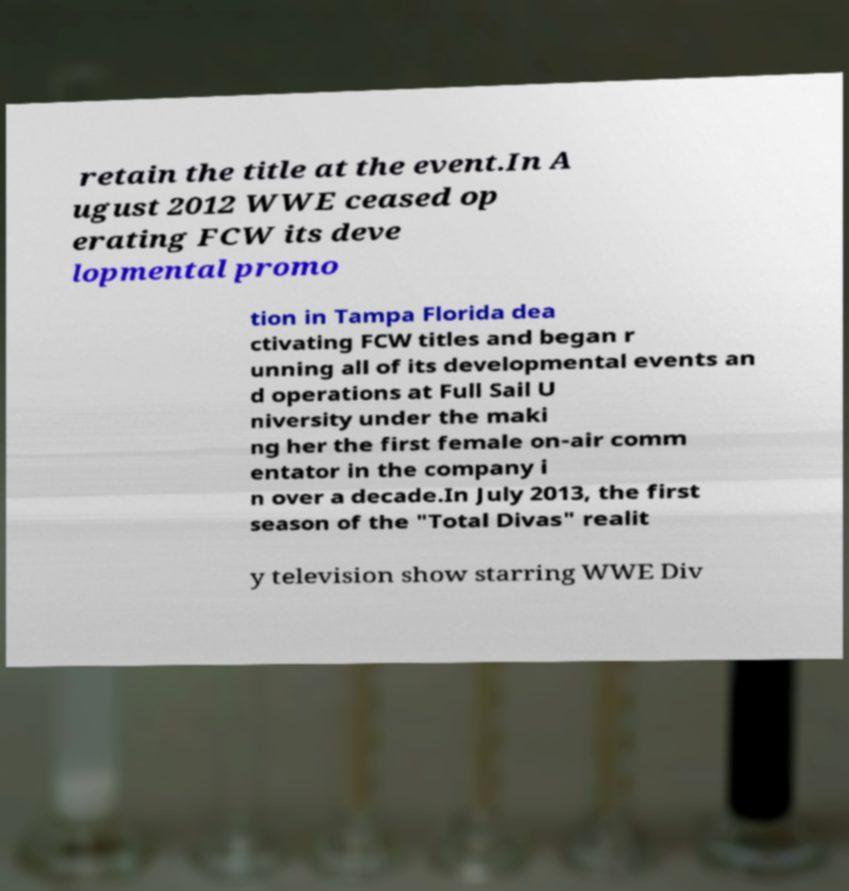I need the written content from this picture converted into text. Can you do that? retain the title at the event.In A ugust 2012 WWE ceased op erating FCW its deve lopmental promo tion in Tampa Florida dea ctivating FCW titles and began r unning all of its developmental events an d operations at Full Sail U niversity under the maki ng her the first female on-air comm entator in the company i n over a decade.In July 2013, the first season of the "Total Divas" realit y television show starring WWE Div 